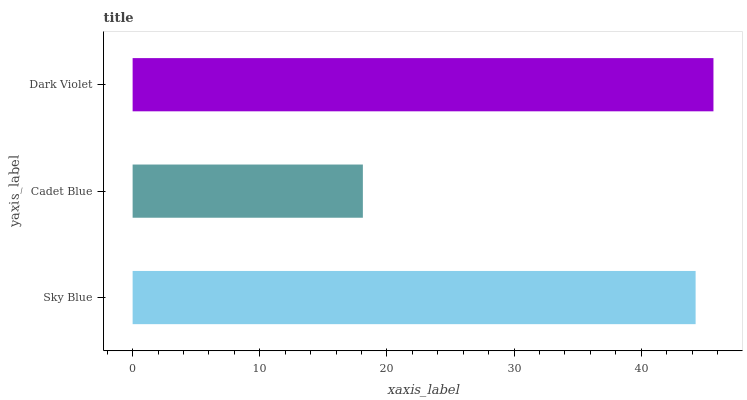Is Cadet Blue the minimum?
Answer yes or no. Yes. Is Dark Violet the maximum?
Answer yes or no. Yes. Is Dark Violet the minimum?
Answer yes or no. No. Is Cadet Blue the maximum?
Answer yes or no. No. Is Dark Violet greater than Cadet Blue?
Answer yes or no. Yes. Is Cadet Blue less than Dark Violet?
Answer yes or no. Yes. Is Cadet Blue greater than Dark Violet?
Answer yes or no. No. Is Dark Violet less than Cadet Blue?
Answer yes or no. No. Is Sky Blue the high median?
Answer yes or no. Yes. Is Sky Blue the low median?
Answer yes or no. Yes. Is Dark Violet the high median?
Answer yes or no. No. Is Dark Violet the low median?
Answer yes or no. No. 